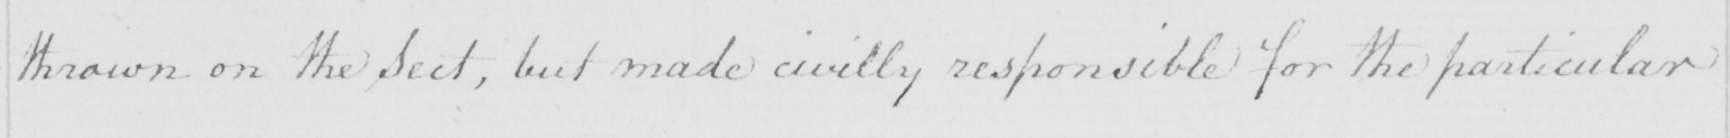What is written in this line of handwriting? thrown on the Sect , but made civilly responsible for the particular 